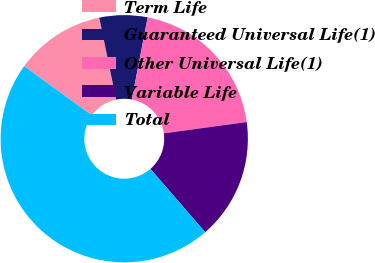Convert chart. <chart><loc_0><loc_0><loc_500><loc_500><pie_chart><fcel>Term Life<fcel>Guaranteed Universal Life(1)<fcel>Other Universal Life(1)<fcel>Variable Life<fcel>Total<nl><fcel>11.78%<fcel>6.28%<fcel>19.8%<fcel>15.79%<fcel>46.35%<nl></chart> 